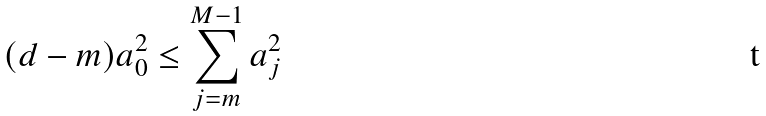Convert formula to latex. <formula><loc_0><loc_0><loc_500><loc_500>( d - m ) a _ { 0 } ^ { 2 } \leq \sum _ { j = m } ^ { M - 1 } a _ { j } ^ { 2 }</formula> 